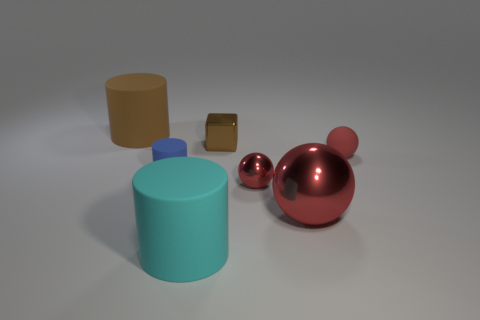Imagine if these objects were real, what could they be used for? Well, if these objects were real and to scale, the cylinders could be containers or stands, the cube might be a paperweight or a decorative object, and the spheres could serve as ornaments or parts of a larger art installation considering their polished look. 